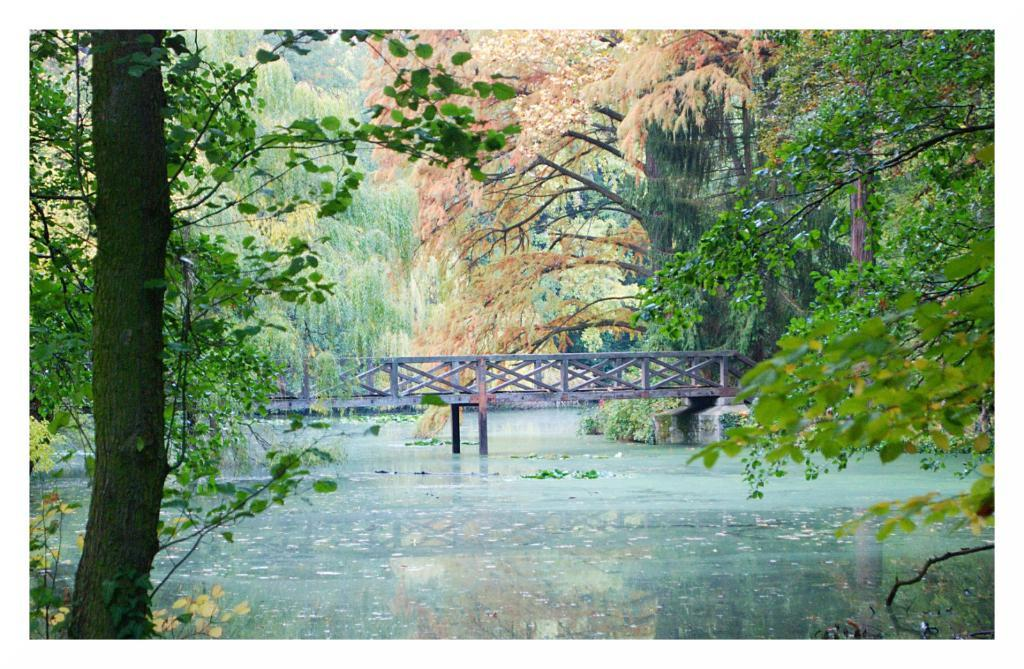What is the main structure in the image? There is a bridge in the image. What is the bridge positioned over? The bridge is across the water. What can be seen in the background behind the bridge? There are trees visible behind the bridge. What type of car is parked on the bridge in the image? There is no car present on the bridge in the image. 